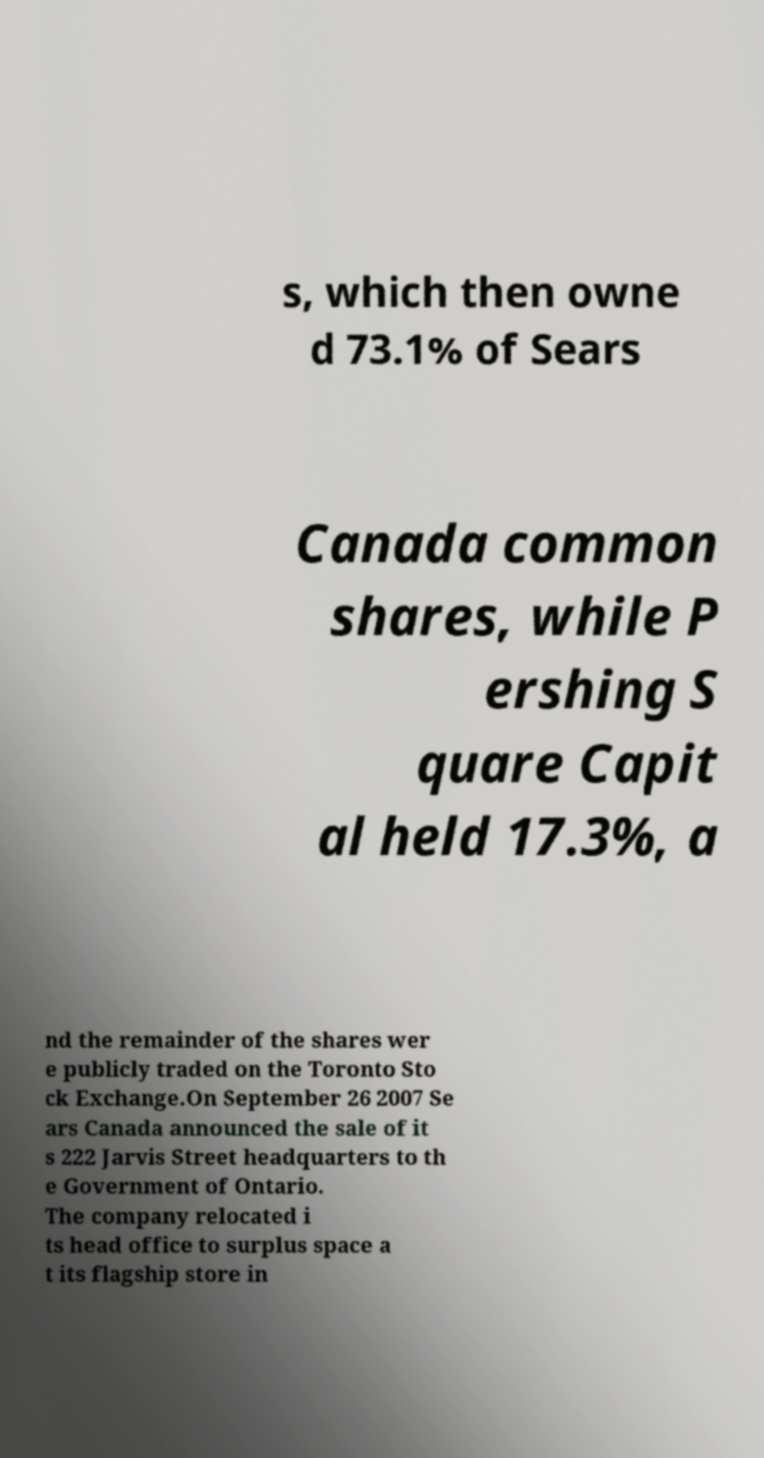Can you accurately transcribe the text from the provided image for me? s, which then owne d 73.1% of Sears Canada common shares, while P ershing S quare Capit al held 17.3%, a nd the remainder of the shares wer e publicly traded on the Toronto Sto ck Exchange.On September 26 2007 Se ars Canada announced the sale of it s 222 Jarvis Street headquarters to th e Government of Ontario. The company relocated i ts head office to surplus space a t its flagship store in 